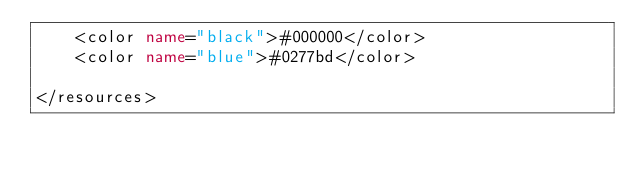<code> <loc_0><loc_0><loc_500><loc_500><_XML_>    <color name="black">#000000</color>
    <color name="blue">#0277bd</color>

</resources></code> 